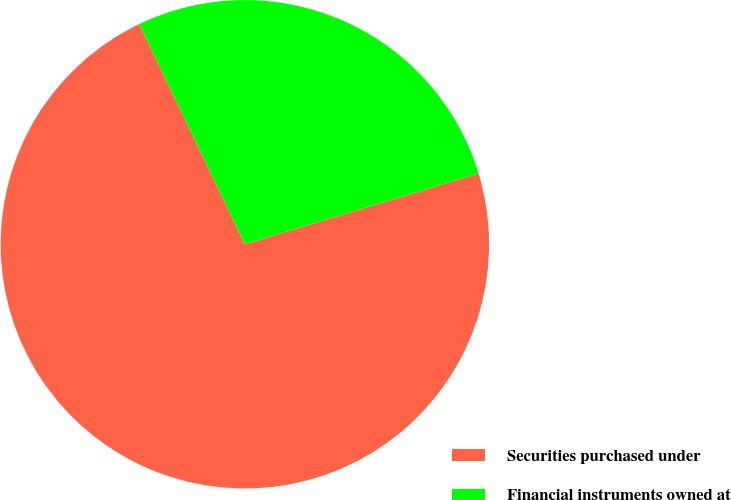Convert chart to OTSL. <chart><loc_0><loc_0><loc_500><loc_500><pie_chart><fcel>Securities purchased under<fcel>Financial instruments owned at<nl><fcel>72.56%<fcel>27.44%<nl></chart> 